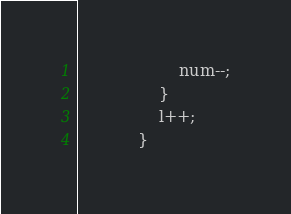Convert code to text. <code><loc_0><loc_0><loc_500><loc_500><_Java_>                    num--;
                }
                l++;
            }</code> 